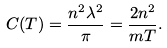Convert formula to latex. <formula><loc_0><loc_0><loc_500><loc_500>C ( T ) = \frac { n ^ { 2 } \lambda ^ { 2 } } { \pi } = \frac { 2 n ^ { 2 } } { m T } .</formula> 